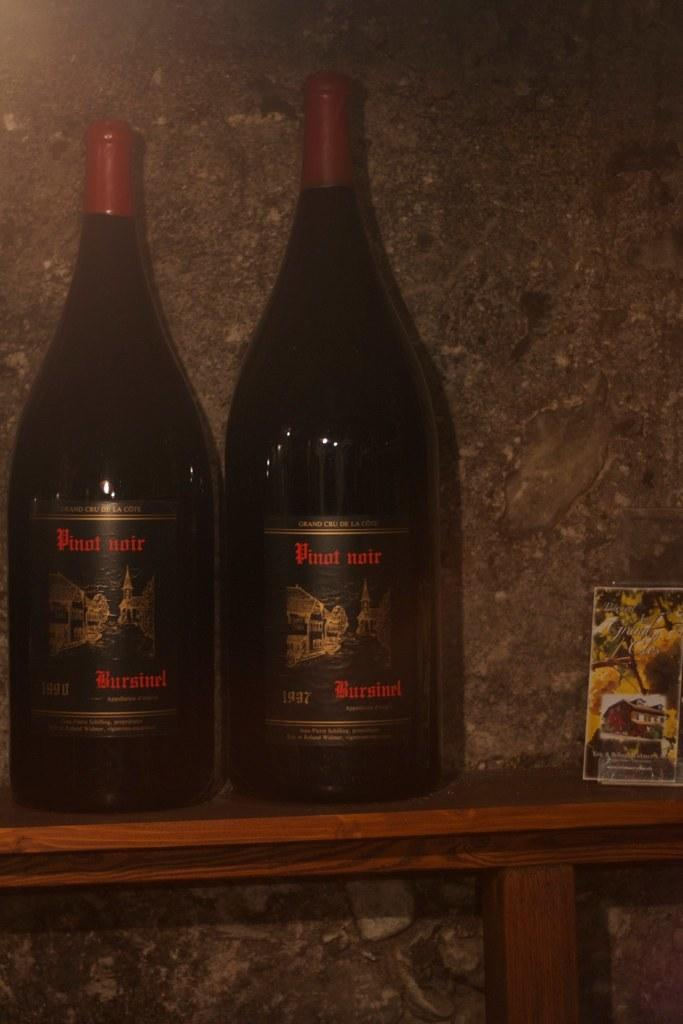Provide a one-sentence caption for the provided image. Two bottles of Pinot Noir wine from 1937 on a wood shelf. 